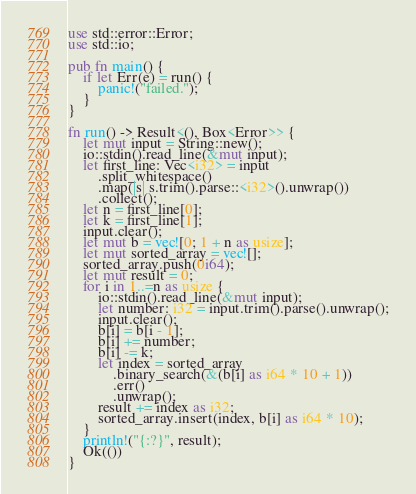<code> <loc_0><loc_0><loc_500><loc_500><_Rust_>use std::error::Error;
use std::io;

pub fn main() {
    if let Err(e) = run() {
        panic!("failed.");
    }
}

fn run() -> Result<(), Box<Error>> {
    let mut input = String::new();
    io::stdin().read_line(&mut input);
    let first_line: Vec<i32> = input
        .split_whitespace()
        .map(|s| s.trim().parse::<i32>().unwrap())
        .collect();
    let n = first_line[0];
    let k = first_line[1];
    input.clear();
    let mut b = vec![0; 1 + n as usize];
    let mut sorted_array = vec![];
    sorted_array.push(0i64);
    let mut result = 0;
    for i in 1..=n as usize {
        io::stdin().read_line(&mut input);
        let number: i32 = input.trim().parse().unwrap();
        input.clear();
        b[i] = b[i - 1];
        b[i] += number;
        b[i] -= k;
        let index = sorted_array
            .binary_search(&(b[i] as i64 * 10 + 1))
            .err()
            .unwrap();
        result += index as i32;
        sorted_array.insert(index, b[i] as i64 * 10);
    }
    println!("{:?}", result);
    Ok(())
}
</code> 